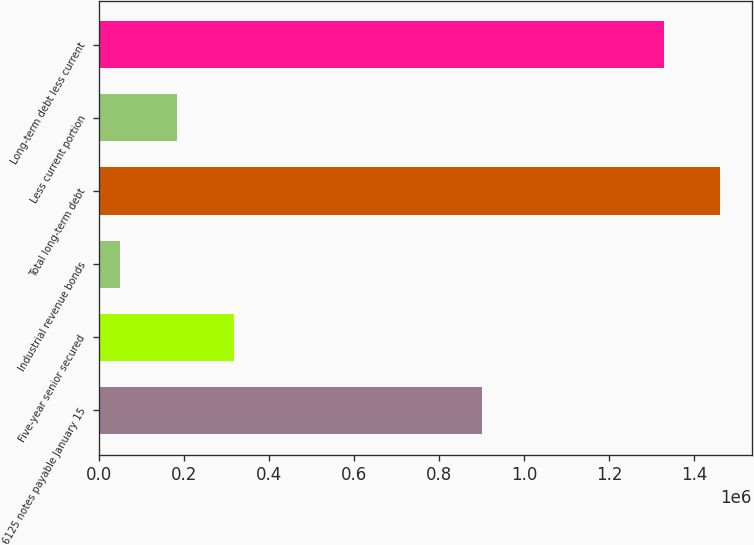Convert chart. <chart><loc_0><loc_0><loc_500><loc_500><bar_chart><fcel>6125 notes payable January 15<fcel>Five-year senior secured<fcel>Industrial revenue bonds<fcel>Total long-term debt<fcel>Less current portion<fcel>Long-term debt less current<nl><fcel>900000<fcel>315842<fcel>49067<fcel>1.46112e+06<fcel>182454<fcel>1.32773e+06<nl></chart> 